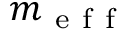Convert formula to latex. <formula><loc_0><loc_0><loc_500><loc_500>m _ { e f f }</formula> 